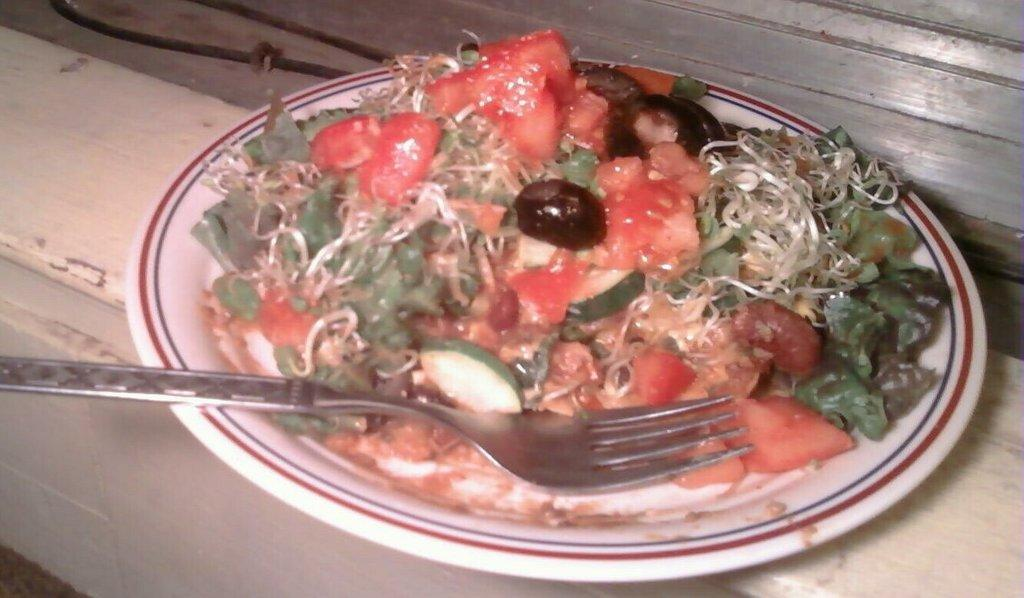What is present on the object in the image? There is a plate in the image. What is the plate resting on? The plate is on an object. What utensil can be seen on the plate? There is a fork on the plate. What is the purpose of the items on the plate? There are food items on the plate, suggesting that it is being used for eating. What type of leather material is used to make the comb in the image? There is no comb or leather material present in the image. 